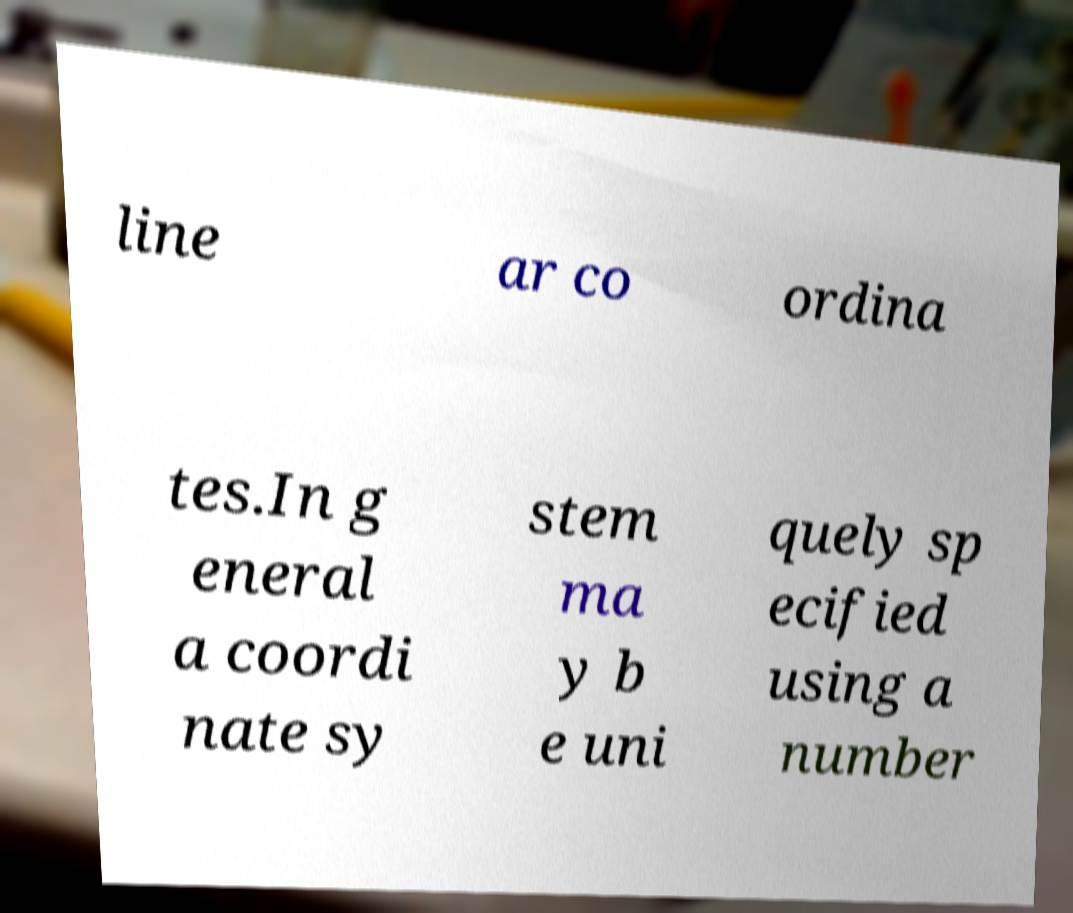Can you read and provide the text displayed in the image?This photo seems to have some interesting text. Can you extract and type it out for me? line ar co ordina tes.In g eneral a coordi nate sy stem ma y b e uni quely sp ecified using a number 